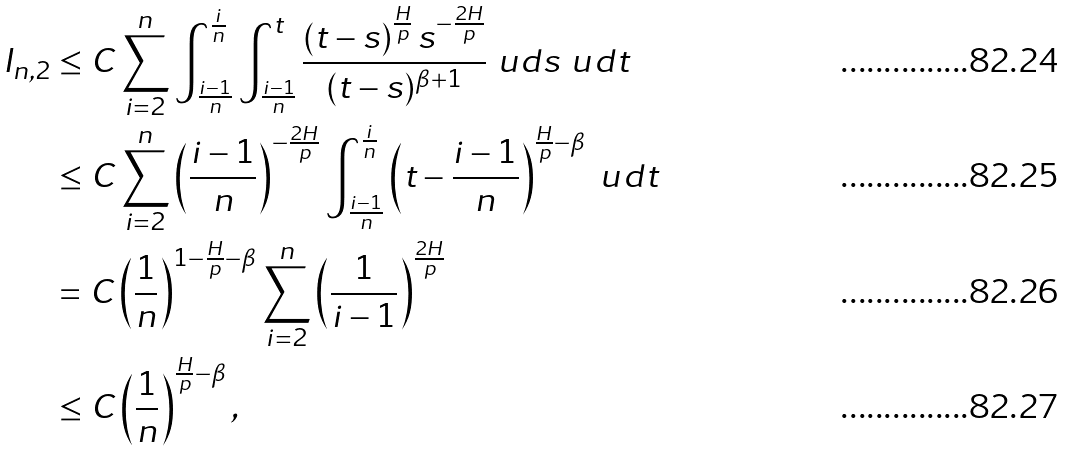Convert formula to latex. <formula><loc_0><loc_0><loc_500><loc_500>I _ { n , 2 } & \leq C \sum _ { i = 2 } ^ { n } \int _ { \frac { i - 1 } { n } } ^ { \frac { i } { n } } \int _ { \frac { i - 1 } { n } } ^ { t } \frac { \left ( t - s \right ) ^ { \frac { H } { p } } s ^ { - \frac { 2 H } { p } } } { ( t - s ) ^ { \beta + 1 } } \ u d s \ u d t \\ & \leq C \sum _ { i = 2 } ^ { n } \left ( \frac { i - 1 } { n } \right ) ^ { - \frac { 2 H } { p } } \int _ { \frac { i - 1 } { n } } ^ { \frac { i } { n } } \left ( t - \frac { i - 1 } { n } \right ) ^ { \frac { H } { p } - \beta } \ u d t \\ & = C \left ( \frac { 1 } { n } \right ) ^ { 1 - \frac { H } { p } - \beta } \sum _ { i = 2 } ^ { n } \left ( \frac { 1 } { i - 1 } \right ) ^ { \frac { 2 H } { p } } \\ & \leq C \left ( \frac { 1 } { n } \right ) ^ { \frac { H } { p } - \beta } ,</formula> 